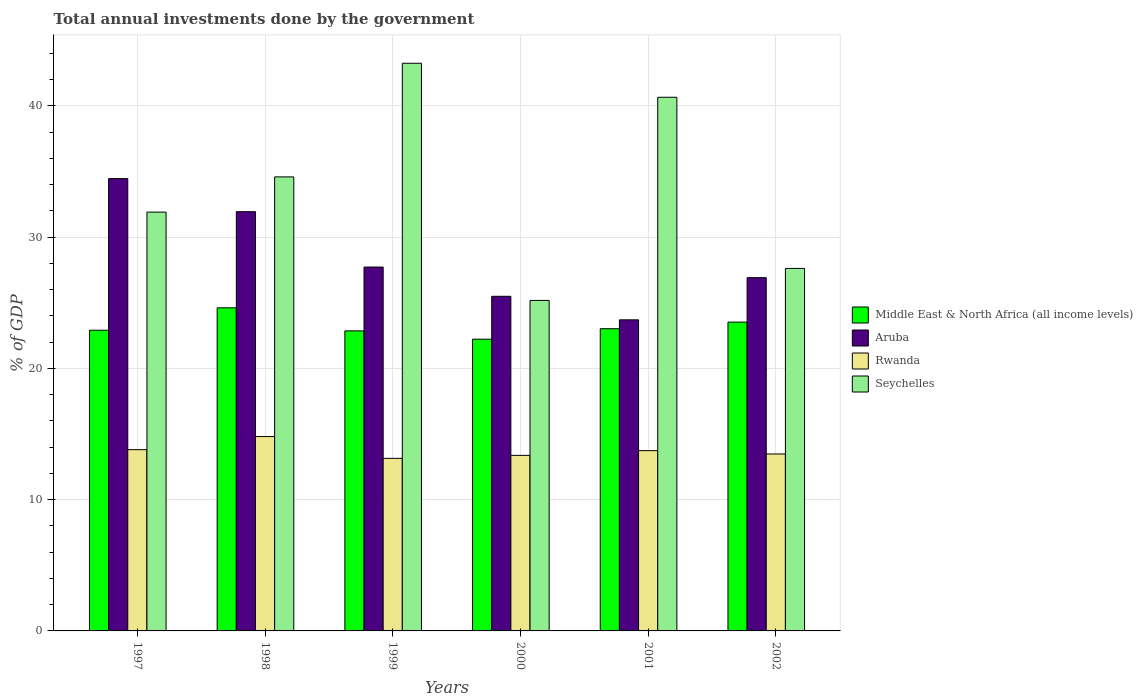What is the label of the 6th group of bars from the left?
Ensure brevity in your answer.  2002. In how many cases, is the number of bars for a given year not equal to the number of legend labels?
Keep it short and to the point. 0. What is the total annual investments done by the government in Aruba in 1997?
Your response must be concise. 34.46. Across all years, what is the maximum total annual investments done by the government in Rwanda?
Provide a short and direct response. 14.81. Across all years, what is the minimum total annual investments done by the government in Rwanda?
Ensure brevity in your answer.  13.15. In which year was the total annual investments done by the government in Seychelles maximum?
Your response must be concise. 1999. What is the total total annual investments done by the government in Middle East & North Africa (all income levels) in the graph?
Your answer should be compact. 139.17. What is the difference between the total annual investments done by the government in Seychelles in 2000 and that in 2002?
Make the answer very short. -2.44. What is the difference between the total annual investments done by the government in Middle East & North Africa (all income levels) in 2000 and the total annual investments done by the government in Seychelles in 1997?
Keep it short and to the point. -9.68. What is the average total annual investments done by the government in Middle East & North Africa (all income levels) per year?
Your answer should be very brief. 23.19. In the year 2002, what is the difference between the total annual investments done by the government in Middle East & North Africa (all income levels) and total annual investments done by the government in Aruba?
Your response must be concise. -3.39. What is the ratio of the total annual investments done by the government in Seychelles in 1998 to that in 2000?
Your response must be concise. 1.37. Is the total annual investments done by the government in Middle East & North Africa (all income levels) in 2000 less than that in 2001?
Provide a succinct answer. Yes. What is the difference between the highest and the second highest total annual investments done by the government in Middle East & North Africa (all income levels)?
Offer a terse response. 1.09. What is the difference between the highest and the lowest total annual investments done by the government in Seychelles?
Your answer should be compact. 18.07. In how many years, is the total annual investments done by the government in Aruba greater than the average total annual investments done by the government in Aruba taken over all years?
Provide a succinct answer. 2. Is the sum of the total annual investments done by the government in Aruba in 1997 and 2000 greater than the maximum total annual investments done by the government in Middle East & North Africa (all income levels) across all years?
Offer a terse response. Yes. Is it the case that in every year, the sum of the total annual investments done by the government in Middle East & North Africa (all income levels) and total annual investments done by the government in Aruba is greater than the sum of total annual investments done by the government in Rwanda and total annual investments done by the government in Seychelles?
Your response must be concise. No. What does the 1st bar from the left in 2001 represents?
Your answer should be compact. Middle East & North Africa (all income levels). What does the 4th bar from the right in 2002 represents?
Offer a very short reply. Middle East & North Africa (all income levels). Is it the case that in every year, the sum of the total annual investments done by the government in Rwanda and total annual investments done by the government in Seychelles is greater than the total annual investments done by the government in Aruba?
Your answer should be very brief. Yes. How many years are there in the graph?
Keep it short and to the point. 6. What is the difference between two consecutive major ticks on the Y-axis?
Offer a terse response. 10. Are the values on the major ticks of Y-axis written in scientific E-notation?
Your answer should be compact. No. Does the graph contain any zero values?
Your answer should be compact. No. Does the graph contain grids?
Provide a short and direct response. Yes. Where does the legend appear in the graph?
Your answer should be very brief. Center right. How many legend labels are there?
Your answer should be very brief. 4. How are the legend labels stacked?
Provide a short and direct response. Vertical. What is the title of the graph?
Keep it short and to the point. Total annual investments done by the government. What is the label or title of the X-axis?
Give a very brief answer. Years. What is the label or title of the Y-axis?
Provide a succinct answer. % of GDP. What is the % of GDP of Middle East & North Africa (all income levels) in 1997?
Your response must be concise. 22.91. What is the % of GDP in Aruba in 1997?
Make the answer very short. 34.46. What is the % of GDP in Rwanda in 1997?
Provide a succinct answer. 13.81. What is the % of GDP in Seychelles in 1997?
Ensure brevity in your answer.  31.91. What is the % of GDP in Middle East & North Africa (all income levels) in 1998?
Give a very brief answer. 24.62. What is the % of GDP of Aruba in 1998?
Your answer should be compact. 31.94. What is the % of GDP in Rwanda in 1998?
Ensure brevity in your answer.  14.81. What is the % of GDP in Seychelles in 1998?
Make the answer very short. 34.59. What is the % of GDP of Middle East & North Africa (all income levels) in 1999?
Make the answer very short. 22.86. What is the % of GDP in Aruba in 1999?
Provide a short and direct response. 27.72. What is the % of GDP in Rwanda in 1999?
Your answer should be very brief. 13.15. What is the % of GDP in Seychelles in 1999?
Your response must be concise. 43.25. What is the % of GDP of Middle East & North Africa (all income levels) in 2000?
Provide a succinct answer. 22.23. What is the % of GDP in Aruba in 2000?
Provide a succinct answer. 25.49. What is the % of GDP in Rwanda in 2000?
Provide a succinct answer. 13.38. What is the % of GDP of Seychelles in 2000?
Ensure brevity in your answer.  25.18. What is the % of GDP in Middle East & North Africa (all income levels) in 2001?
Give a very brief answer. 23.03. What is the % of GDP of Aruba in 2001?
Offer a terse response. 23.7. What is the % of GDP in Rwanda in 2001?
Provide a succinct answer. 13.74. What is the % of GDP in Seychelles in 2001?
Make the answer very short. 40.66. What is the % of GDP of Middle East & North Africa (all income levels) in 2002?
Offer a very short reply. 23.53. What is the % of GDP of Aruba in 2002?
Ensure brevity in your answer.  26.91. What is the % of GDP of Rwanda in 2002?
Keep it short and to the point. 13.48. What is the % of GDP in Seychelles in 2002?
Offer a very short reply. 27.62. Across all years, what is the maximum % of GDP in Middle East & North Africa (all income levels)?
Provide a succinct answer. 24.62. Across all years, what is the maximum % of GDP in Aruba?
Provide a short and direct response. 34.46. Across all years, what is the maximum % of GDP of Rwanda?
Your answer should be very brief. 14.81. Across all years, what is the maximum % of GDP in Seychelles?
Offer a very short reply. 43.25. Across all years, what is the minimum % of GDP in Middle East & North Africa (all income levels)?
Provide a succinct answer. 22.23. Across all years, what is the minimum % of GDP of Aruba?
Offer a very short reply. 23.7. Across all years, what is the minimum % of GDP in Rwanda?
Make the answer very short. 13.15. Across all years, what is the minimum % of GDP in Seychelles?
Make the answer very short. 25.18. What is the total % of GDP of Middle East & North Africa (all income levels) in the graph?
Your response must be concise. 139.17. What is the total % of GDP of Aruba in the graph?
Provide a succinct answer. 170.24. What is the total % of GDP of Rwanda in the graph?
Provide a succinct answer. 82.36. What is the total % of GDP in Seychelles in the graph?
Offer a very short reply. 203.21. What is the difference between the % of GDP of Middle East & North Africa (all income levels) in 1997 and that in 1998?
Offer a terse response. -1.71. What is the difference between the % of GDP of Aruba in 1997 and that in 1998?
Your answer should be very brief. 2.52. What is the difference between the % of GDP of Rwanda in 1997 and that in 1998?
Ensure brevity in your answer.  -1. What is the difference between the % of GDP in Seychelles in 1997 and that in 1998?
Provide a succinct answer. -2.68. What is the difference between the % of GDP in Middle East & North Africa (all income levels) in 1997 and that in 1999?
Offer a very short reply. 0.05. What is the difference between the % of GDP of Aruba in 1997 and that in 1999?
Ensure brevity in your answer.  6.74. What is the difference between the % of GDP in Rwanda in 1997 and that in 1999?
Make the answer very short. 0.66. What is the difference between the % of GDP in Seychelles in 1997 and that in 1999?
Offer a very short reply. -11.34. What is the difference between the % of GDP in Middle East & North Africa (all income levels) in 1997 and that in 2000?
Give a very brief answer. 0.68. What is the difference between the % of GDP in Aruba in 1997 and that in 2000?
Ensure brevity in your answer.  8.97. What is the difference between the % of GDP in Rwanda in 1997 and that in 2000?
Offer a terse response. 0.43. What is the difference between the % of GDP of Seychelles in 1997 and that in 2000?
Keep it short and to the point. 6.73. What is the difference between the % of GDP of Middle East & North Africa (all income levels) in 1997 and that in 2001?
Provide a succinct answer. -0.12. What is the difference between the % of GDP in Aruba in 1997 and that in 2001?
Keep it short and to the point. 10.76. What is the difference between the % of GDP in Rwanda in 1997 and that in 2001?
Your answer should be compact. 0.07. What is the difference between the % of GDP of Seychelles in 1997 and that in 2001?
Provide a short and direct response. -8.75. What is the difference between the % of GDP in Middle East & North Africa (all income levels) in 1997 and that in 2002?
Give a very brief answer. -0.62. What is the difference between the % of GDP in Aruba in 1997 and that in 2002?
Your answer should be very brief. 7.55. What is the difference between the % of GDP of Rwanda in 1997 and that in 2002?
Keep it short and to the point. 0.33. What is the difference between the % of GDP of Seychelles in 1997 and that in 2002?
Offer a very short reply. 4.29. What is the difference between the % of GDP in Middle East & North Africa (all income levels) in 1998 and that in 1999?
Your response must be concise. 1.76. What is the difference between the % of GDP of Aruba in 1998 and that in 1999?
Offer a terse response. 4.22. What is the difference between the % of GDP of Rwanda in 1998 and that in 1999?
Make the answer very short. 1.66. What is the difference between the % of GDP of Seychelles in 1998 and that in 1999?
Offer a terse response. -8.66. What is the difference between the % of GDP of Middle East & North Africa (all income levels) in 1998 and that in 2000?
Your answer should be very brief. 2.39. What is the difference between the % of GDP of Aruba in 1998 and that in 2000?
Keep it short and to the point. 6.45. What is the difference between the % of GDP of Rwanda in 1998 and that in 2000?
Your response must be concise. 1.43. What is the difference between the % of GDP in Seychelles in 1998 and that in 2000?
Your response must be concise. 9.41. What is the difference between the % of GDP in Middle East & North Africa (all income levels) in 1998 and that in 2001?
Provide a succinct answer. 1.59. What is the difference between the % of GDP of Aruba in 1998 and that in 2001?
Your response must be concise. 8.24. What is the difference between the % of GDP of Rwanda in 1998 and that in 2001?
Give a very brief answer. 1.07. What is the difference between the % of GDP of Seychelles in 1998 and that in 2001?
Give a very brief answer. -6.07. What is the difference between the % of GDP in Middle East & North Africa (all income levels) in 1998 and that in 2002?
Provide a succinct answer. 1.09. What is the difference between the % of GDP in Aruba in 1998 and that in 2002?
Offer a terse response. 5.03. What is the difference between the % of GDP in Rwanda in 1998 and that in 2002?
Provide a short and direct response. 1.33. What is the difference between the % of GDP in Seychelles in 1998 and that in 2002?
Ensure brevity in your answer.  6.97. What is the difference between the % of GDP in Middle East & North Africa (all income levels) in 1999 and that in 2000?
Your answer should be very brief. 0.63. What is the difference between the % of GDP of Aruba in 1999 and that in 2000?
Provide a short and direct response. 2.23. What is the difference between the % of GDP in Rwanda in 1999 and that in 2000?
Offer a terse response. -0.23. What is the difference between the % of GDP of Seychelles in 1999 and that in 2000?
Offer a very short reply. 18.07. What is the difference between the % of GDP of Middle East & North Africa (all income levels) in 1999 and that in 2001?
Make the answer very short. -0.17. What is the difference between the % of GDP in Aruba in 1999 and that in 2001?
Offer a very short reply. 4.02. What is the difference between the % of GDP in Rwanda in 1999 and that in 2001?
Keep it short and to the point. -0.59. What is the difference between the % of GDP of Seychelles in 1999 and that in 2001?
Provide a succinct answer. 2.59. What is the difference between the % of GDP in Middle East & North Africa (all income levels) in 1999 and that in 2002?
Offer a very short reply. -0.67. What is the difference between the % of GDP in Aruba in 1999 and that in 2002?
Your answer should be very brief. 0.81. What is the difference between the % of GDP in Rwanda in 1999 and that in 2002?
Make the answer very short. -0.33. What is the difference between the % of GDP in Seychelles in 1999 and that in 2002?
Offer a very short reply. 15.63. What is the difference between the % of GDP of Middle East & North Africa (all income levels) in 2000 and that in 2001?
Keep it short and to the point. -0.8. What is the difference between the % of GDP in Aruba in 2000 and that in 2001?
Your answer should be compact. 1.79. What is the difference between the % of GDP in Rwanda in 2000 and that in 2001?
Provide a short and direct response. -0.36. What is the difference between the % of GDP in Seychelles in 2000 and that in 2001?
Offer a very short reply. -15.48. What is the difference between the % of GDP of Middle East & North Africa (all income levels) in 2000 and that in 2002?
Your answer should be compact. -1.3. What is the difference between the % of GDP in Aruba in 2000 and that in 2002?
Your answer should be very brief. -1.42. What is the difference between the % of GDP of Rwanda in 2000 and that in 2002?
Ensure brevity in your answer.  -0.11. What is the difference between the % of GDP of Seychelles in 2000 and that in 2002?
Provide a succinct answer. -2.44. What is the difference between the % of GDP of Middle East & North Africa (all income levels) in 2001 and that in 2002?
Your response must be concise. -0.5. What is the difference between the % of GDP of Aruba in 2001 and that in 2002?
Keep it short and to the point. -3.21. What is the difference between the % of GDP of Rwanda in 2001 and that in 2002?
Make the answer very short. 0.25. What is the difference between the % of GDP in Seychelles in 2001 and that in 2002?
Give a very brief answer. 13.04. What is the difference between the % of GDP in Middle East & North Africa (all income levels) in 1997 and the % of GDP in Aruba in 1998?
Provide a short and direct response. -9.03. What is the difference between the % of GDP in Middle East & North Africa (all income levels) in 1997 and the % of GDP in Rwanda in 1998?
Ensure brevity in your answer.  8.1. What is the difference between the % of GDP in Middle East & North Africa (all income levels) in 1997 and the % of GDP in Seychelles in 1998?
Your answer should be compact. -11.68. What is the difference between the % of GDP in Aruba in 1997 and the % of GDP in Rwanda in 1998?
Provide a succinct answer. 19.66. What is the difference between the % of GDP in Aruba in 1997 and the % of GDP in Seychelles in 1998?
Give a very brief answer. -0.13. What is the difference between the % of GDP of Rwanda in 1997 and the % of GDP of Seychelles in 1998?
Make the answer very short. -20.78. What is the difference between the % of GDP in Middle East & North Africa (all income levels) in 1997 and the % of GDP in Aruba in 1999?
Your response must be concise. -4.82. What is the difference between the % of GDP in Middle East & North Africa (all income levels) in 1997 and the % of GDP in Rwanda in 1999?
Keep it short and to the point. 9.76. What is the difference between the % of GDP of Middle East & North Africa (all income levels) in 1997 and the % of GDP of Seychelles in 1999?
Keep it short and to the point. -20.34. What is the difference between the % of GDP in Aruba in 1997 and the % of GDP in Rwanda in 1999?
Make the answer very short. 21.32. What is the difference between the % of GDP of Aruba in 1997 and the % of GDP of Seychelles in 1999?
Your response must be concise. -8.79. What is the difference between the % of GDP in Rwanda in 1997 and the % of GDP in Seychelles in 1999?
Make the answer very short. -29.44. What is the difference between the % of GDP of Middle East & North Africa (all income levels) in 1997 and the % of GDP of Aruba in 2000?
Your response must be concise. -2.59. What is the difference between the % of GDP of Middle East & North Africa (all income levels) in 1997 and the % of GDP of Rwanda in 2000?
Your response must be concise. 9.53. What is the difference between the % of GDP in Middle East & North Africa (all income levels) in 1997 and the % of GDP in Seychelles in 2000?
Provide a succinct answer. -2.27. What is the difference between the % of GDP in Aruba in 1997 and the % of GDP in Rwanda in 2000?
Ensure brevity in your answer.  21.09. What is the difference between the % of GDP in Aruba in 1997 and the % of GDP in Seychelles in 2000?
Give a very brief answer. 9.28. What is the difference between the % of GDP of Rwanda in 1997 and the % of GDP of Seychelles in 2000?
Make the answer very short. -11.37. What is the difference between the % of GDP in Middle East & North Africa (all income levels) in 1997 and the % of GDP in Aruba in 2001?
Make the answer very short. -0.79. What is the difference between the % of GDP in Middle East & North Africa (all income levels) in 1997 and the % of GDP in Rwanda in 2001?
Offer a very short reply. 9.17. What is the difference between the % of GDP of Middle East & North Africa (all income levels) in 1997 and the % of GDP of Seychelles in 2001?
Keep it short and to the point. -17.75. What is the difference between the % of GDP in Aruba in 1997 and the % of GDP in Rwanda in 2001?
Ensure brevity in your answer.  20.73. What is the difference between the % of GDP of Aruba in 1997 and the % of GDP of Seychelles in 2001?
Your response must be concise. -6.2. What is the difference between the % of GDP in Rwanda in 1997 and the % of GDP in Seychelles in 2001?
Provide a succinct answer. -26.85. What is the difference between the % of GDP of Middle East & North Africa (all income levels) in 1997 and the % of GDP of Aruba in 2002?
Offer a very short reply. -4.01. What is the difference between the % of GDP in Middle East & North Africa (all income levels) in 1997 and the % of GDP in Rwanda in 2002?
Offer a terse response. 9.43. What is the difference between the % of GDP in Middle East & North Africa (all income levels) in 1997 and the % of GDP in Seychelles in 2002?
Your answer should be compact. -4.71. What is the difference between the % of GDP in Aruba in 1997 and the % of GDP in Rwanda in 2002?
Your answer should be compact. 20.98. What is the difference between the % of GDP of Aruba in 1997 and the % of GDP of Seychelles in 2002?
Your answer should be compact. 6.84. What is the difference between the % of GDP in Rwanda in 1997 and the % of GDP in Seychelles in 2002?
Keep it short and to the point. -13.81. What is the difference between the % of GDP in Middle East & North Africa (all income levels) in 1998 and the % of GDP in Aruba in 1999?
Your answer should be compact. -3.11. What is the difference between the % of GDP in Middle East & North Africa (all income levels) in 1998 and the % of GDP in Rwanda in 1999?
Provide a short and direct response. 11.47. What is the difference between the % of GDP in Middle East & North Africa (all income levels) in 1998 and the % of GDP in Seychelles in 1999?
Ensure brevity in your answer.  -18.63. What is the difference between the % of GDP in Aruba in 1998 and the % of GDP in Rwanda in 1999?
Your answer should be compact. 18.79. What is the difference between the % of GDP of Aruba in 1998 and the % of GDP of Seychelles in 1999?
Ensure brevity in your answer.  -11.31. What is the difference between the % of GDP of Rwanda in 1998 and the % of GDP of Seychelles in 1999?
Provide a short and direct response. -28.44. What is the difference between the % of GDP in Middle East & North Africa (all income levels) in 1998 and the % of GDP in Aruba in 2000?
Provide a succinct answer. -0.88. What is the difference between the % of GDP of Middle East & North Africa (all income levels) in 1998 and the % of GDP of Rwanda in 2000?
Your response must be concise. 11.24. What is the difference between the % of GDP of Middle East & North Africa (all income levels) in 1998 and the % of GDP of Seychelles in 2000?
Make the answer very short. -0.56. What is the difference between the % of GDP in Aruba in 1998 and the % of GDP in Rwanda in 2000?
Keep it short and to the point. 18.57. What is the difference between the % of GDP in Aruba in 1998 and the % of GDP in Seychelles in 2000?
Your answer should be very brief. 6.76. What is the difference between the % of GDP of Rwanda in 1998 and the % of GDP of Seychelles in 2000?
Offer a very short reply. -10.37. What is the difference between the % of GDP in Middle East & North Africa (all income levels) in 1998 and the % of GDP in Aruba in 2001?
Your answer should be very brief. 0.92. What is the difference between the % of GDP of Middle East & North Africa (all income levels) in 1998 and the % of GDP of Rwanda in 2001?
Your answer should be compact. 10.88. What is the difference between the % of GDP of Middle East & North Africa (all income levels) in 1998 and the % of GDP of Seychelles in 2001?
Your answer should be very brief. -16.04. What is the difference between the % of GDP of Aruba in 1998 and the % of GDP of Rwanda in 2001?
Make the answer very short. 18.21. What is the difference between the % of GDP in Aruba in 1998 and the % of GDP in Seychelles in 2001?
Give a very brief answer. -8.72. What is the difference between the % of GDP in Rwanda in 1998 and the % of GDP in Seychelles in 2001?
Your answer should be compact. -25.85. What is the difference between the % of GDP in Middle East & North Africa (all income levels) in 1998 and the % of GDP in Aruba in 2002?
Your answer should be compact. -2.3. What is the difference between the % of GDP of Middle East & North Africa (all income levels) in 1998 and the % of GDP of Rwanda in 2002?
Your answer should be compact. 11.14. What is the difference between the % of GDP of Middle East & North Africa (all income levels) in 1998 and the % of GDP of Seychelles in 2002?
Your answer should be very brief. -3. What is the difference between the % of GDP in Aruba in 1998 and the % of GDP in Rwanda in 2002?
Give a very brief answer. 18.46. What is the difference between the % of GDP of Aruba in 1998 and the % of GDP of Seychelles in 2002?
Provide a succinct answer. 4.32. What is the difference between the % of GDP in Rwanda in 1998 and the % of GDP in Seychelles in 2002?
Ensure brevity in your answer.  -12.81. What is the difference between the % of GDP of Middle East & North Africa (all income levels) in 1999 and the % of GDP of Aruba in 2000?
Provide a short and direct response. -2.63. What is the difference between the % of GDP in Middle East & North Africa (all income levels) in 1999 and the % of GDP in Rwanda in 2000?
Your answer should be very brief. 9.48. What is the difference between the % of GDP of Middle East & North Africa (all income levels) in 1999 and the % of GDP of Seychelles in 2000?
Your answer should be compact. -2.32. What is the difference between the % of GDP of Aruba in 1999 and the % of GDP of Rwanda in 2000?
Offer a very short reply. 14.35. What is the difference between the % of GDP in Aruba in 1999 and the % of GDP in Seychelles in 2000?
Ensure brevity in your answer.  2.54. What is the difference between the % of GDP in Rwanda in 1999 and the % of GDP in Seychelles in 2000?
Provide a succinct answer. -12.03. What is the difference between the % of GDP in Middle East & North Africa (all income levels) in 1999 and the % of GDP in Aruba in 2001?
Your answer should be very brief. -0.84. What is the difference between the % of GDP in Middle East & North Africa (all income levels) in 1999 and the % of GDP in Rwanda in 2001?
Your answer should be very brief. 9.12. What is the difference between the % of GDP of Middle East & North Africa (all income levels) in 1999 and the % of GDP of Seychelles in 2001?
Your response must be concise. -17.8. What is the difference between the % of GDP in Aruba in 1999 and the % of GDP in Rwanda in 2001?
Your response must be concise. 13.99. What is the difference between the % of GDP of Aruba in 1999 and the % of GDP of Seychelles in 2001?
Give a very brief answer. -12.94. What is the difference between the % of GDP in Rwanda in 1999 and the % of GDP in Seychelles in 2001?
Keep it short and to the point. -27.51. What is the difference between the % of GDP of Middle East & North Africa (all income levels) in 1999 and the % of GDP of Aruba in 2002?
Give a very brief answer. -4.05. What is the difference between the % of GDP in Middle East & North Africa (all income levels) in 1999 and the % of GDP in Rwanda in 2002?
Your response must be concise. 9.38. What is the difference between the % of GDP of Middle East & North Africa (all income levels) in 1999 and the % of GDP of Seychelles in 2002?
Give a very brief answer. -4.76. What is the difference between the % of GDP of Aruba in 1999 and the % of GDP of Rwanda in 2002?
Your answer should be compact. 14.24. What is the difference between the % of GDP in Aruba in 1999 and the % of GDP in Seychelles in 2002?
Provide a short and direct response. 0.1. What is the difference between the % of GDP of Rwanda in 1999 and the % of GDP of Seychelles in 2002?
Give a very brief answer. -14.47. What is the difference between the % of GDP in Middle East & North Africa (all income levels) in 2000 and the % of GDP in Aruba in 2001?
Your answer should be compact. -1.47. What is the difference between the % of GDP in Middle East & North Africa (all income levels) in 2000 and the % of GDP in Rwanda in 2001?
Make the answer very short. 8.49. What is the difference between the % of GDP of Middle East & North Africa (all income levels) in 2000 and the % of GDP of Seychelles in 2001?
Ensure brevity in your answer.  -18.43. What is the difference between the % of GDP of Aruba in 2000 and the % of GDP of Rwanda in 2001?
Offer a very short reply. 11.76. What is the difference between the % of GDP in Aruba in 2000 and the % of GDP in Seychelles in 2001?
Your answer should be very brief. -15.17. What is the difference between the % of GDP of Rwanda in 2000 and the % of GDP of Seychelles in 2001?
Offer a very short reply. -27.28. What is the difference between the % of GDP of Middle East & North Africa (all income levels) in 2000 and the % of GDP of Aruba in 2002?
Ensure brevity in your answer.  -4.69. What is the difference between the % of GDP in Middle East & North Africa (all income levels) in 2000 and the % of GDP in Rwanda in 2002?
Make the answer very short. 8.75. What is the difference between the % of GDP of Middle East & North Africa (all income levels) in 2000 and the % of GDP of Seychelles in 2002?
Keep it short and to the point. -5.39. What is the difference between the % of GDP in Aruba in 2000 and the % of GDP in Rwanda in 2002?
Give a very brief answer. 12.01. What is the difference between the % of GDP in Aruba in 2000 and the % of GDP in Seychelles in 2002?
Give a very brief answer. -2.13. What is the difference between the % of GDP in Rwanda in 2000 and the % of GDP in Seychelles in 2002?
Your response must be concise. -14.24. What is the difference between the % of GDP of Middle East & North Africa (all income levels) in 2001 and the % of GDP of Aruba in 2002?
Your answer should be very brief. -3.89. What is the difference between the % of GDP in Middle East & North Africa (all income levels) in 2001 and the % of GDP in Rwanda in 2002?
Keep it short and to the point. 9.54. What is the difference between the % of GDP of Middle East & North Africa (all income levels) in 2001 and the % of GDP of Seychelles in 2002?
Keep it short and to the point. -4.59. What is the difference between the % of GDP in Aruba in 2001 and the % of GDP in Rwanda in 2002?
Your answer should be very brief. 10.22. What is the difference between the % of GDP in Aruba in 2001 and the % of GDP in Seychelles in 2002?
Ensure brevity in your answer.  -3.92. What is the difference between the % of GDP in Rwanda in 2001 and the % of GDP in Seychelles in 2002?
Your answer should be compact. -13.88. What is the average % of GDP in Middle East & North Africa (all income levels) per year?
Make the answer very short. 23.19. What is the average % of GDP of Aruba per year?
Offer a very short reply. 28.37. What is the average % of GDP of Rwanda per year?
Your answer should be very brief. 13.73. What is the average % of GDP in Seychelles per year?
Offer a terse response. 33.87. In the year 1997, what is the difference between the % of GDP of Middle East & North Africa (all income levels) and % of GDP of Aruba?
Provide a succinct answer. -11.56. In the year 1997, what is the difference between the % of GDP in Middle East & North Africa (all income levels) and % of GDP in Rwanda?
Keep it short and to the point. 9.1. In the year 1997, what is the difference between the % of GDP of Middle East & North Africa (all income levels) and % of GDP of Seychelles?
Make the answer very short. -9. In the year 1997, what is the difference between the % of GDP of Aruba and % of GDP of Rwanda?
Provide a succinct answer. 20.65. In the year 1997, what is the difference between the % of GDP in Aruba and % of GDP in Seychelles?
Keep it short and to the point. 2.55. In the year 1997, what is the difference between the % of GDP of Rwanda and % of GDP of Seychelles?
Your response must be concise. -18.1. In the year 1998, what is the difference between the % of GDP in Middle East & North Africa (all income levels) and % of GDP in Aruba?
Your answer should be very brief. -7.33. In the year 1998, what is the difference between the % of GDP of Middle East & North Africa (all income levels) and % of GDP of Rwanda?
Keep it short and to the point. 9.81. In the year 1998, what is the difference between the % of GDP of Middle East & North Africa (all income levels) and % of GDP of Seychelles?
Keep it short and to the point. -9.97. In the year 1998, what is the difference between the % of GDP in Aruba and % of GDP in Rwanda?
Give a very brief answer. 17.14. In the year 1998, what is the difference between the % of GDP of Aruba and % of GDP of Seychelles?
Keep it short and to the point. -2.65. In the year 1998, what is the difference between the % of GDP of Rwanda and % of GDP of Seychelles?
Ensure brevity in your answer.  -19.78. In the year 1999, what is the difference between the % of GDP in Middle East & North Africa (all income levels) and % of GDP in Aruba?
Make the answer very short. -4.86. In the year 1999, what is the difference between the % of GDP in Middle East & North Africa (all income levels) and % of GDP in Rwanda?
Give a very brief answer. 9.71. In the year 1999, what is the difference between the % of GDP of Middle East & North Africa (all income levels) and % of GDP of Seychelles?
Give a very brief answer. -20.39. In the year 1999, what is the difference between the % of GDP in Aruba and % of GDP in Rwanda?
Your response must be concise. 14.57. In the year 1999, what is the difference between the % of GDP of Aruba and % of GDP of Seychelles?
Your answer should be compact. -15.53. In the year 1999, what is the difference between the % of GDP in Rwanda and % of GDP in Seychelles?
Offer a very short reply. -30.1. In the year 2000, what is the difference between the % of GDP in Middle East & North Africa (all income levels) and % of GDP in Aruba?
Make the answer very short. -3.27. In the year 2000, what is the difference between the % of GDP of Middle East & North Africa (all income levels) and % of GDP of Rwanda?
Your answer should be compact. 8.85. In the year 2000, what is the difference between the % of GDP of Middle East & North Africa (all income levels) and % of GDP of Seychelles?
Provide a short and direct response. -2.95. In the year 2000, what is the difference between the % of GDP in Aruba and % of GDP in Rwanda?
Offer a terse response. 12.12. In the year 2000, what is the difference between the % of GDP of Aruba and % of GDP of Seychelles?
Provide a short and direct response. 0.31. In the year 2000, what is the difference between the % of GDP of Rwanda and % of GDP of Seychelles?
Your answer should be very brief. -11.81. In the year 2001, what is the difference between the % of GDP of Middle East & North Africa (all income levels) and % of GDP of Aruba?
Give a very brief answer. -0.68. In the year 2001, what is the difference between the % of GDP in Middle East & North Africa (all income levels) and % of GDP in Rwanda?
Offer a terse response. 9.29. In the year 2001, what is the difference between the % of GDP of Middle East & North Africa (all income levels) and % of GDP of Seychelles?
Keep it short and to the point. -17.63. In the year 2001, what is the difference between the % of GDP in Aruba and % of GDP in Rwanda?
Provide a succinct answer. 9.97. In the year 2001, what is the difference between the % of GDP in Aruba and % of GDP in Seychelles?
Make the answer very short. -16.96. In the year 2001, what is the difference between the % of GDP of Rwanda and % of GDP of Seychelles?
Offer a terse response. -26.92. In the year 2002, what is the difference between the % of GDP of Middle East & North Africa (all income levels) and % of GDP of Aruba?
Give a very brief answer. -3.39. In the year 2002, what is the difference between the % of GDP in Middle East & North Africa (all income levels) and % of GDP in Rwanda?
Offer a very short reply. 10.05. In the year 2002, what is the difference between the % of GDP of Middle East & North Africa (all income levels) and % of GDP of Seychelles?
Give a very brief answer. -4.09. In the year 2002, what is the difference between the % of GDP in Aruba and % of GDP in Rwanda?
Offer a very short reply. 13.43. In the year 2002, what is the difference between the % of GDP of Aruba and % of GDP of Seychelles?
Keep it short and to the point. -0.7. In the year 2002, what is the difference between the % of GDP in Rwanda and % of GDP in Seychelles?
Your response must be concise. -14.14. What is the ratio of the % of GDP of Middle East & North Africa (all income levels) in 1997 to that in 1998?
Make the answer very short. 0.93. What is the ratio of the % of GDP in Aruba in 1997 to that in 1998?
Offer a very short reply. 1.08. What is the ratio of the % of GDP of Rwanda in 1997 to that in 1998?
Give a very brief answer. 0.93. What is the ratio of the % of GDP of Seychelles in 1997 to that in 1998?
Your answer should be compact. 0.92. What is the ratio of the % of GDP in Aruba in 1997 to that in 1999?
Keep it short and to the point. 1.24. What is the ratio of the % of GDP of Rwanda in 1997 to that in 1999?
Keep it short and to the point. 1.05. What is the ratio of the % of GDP in Seychelles in 1997 to that in 1999?
Your answer should be compact. 0.74. What is the ratio of the % of GDP in Middle East & North Africa (all income levels) in 1997 to that in 2000?
Your answer should be compact. 1.03. What is the ratio of the % of GDP in Aruba in 1997 to that in 2000?
Give a very brief answer. 1.35. What is the ratio of the % of GDP of Rwanda in 1997 to that in 2000?
Make the answer very short. 1.03. What is the ratio of the % of GDP of Seychelles in 1997 to that in 2000?
Keep it short and to the point. 1.27. What is the ratio of the % of GDP of Aruba in 1997 to that in 2001?
Your answer should be compact. 1.45. What is the ratio of the % of GDP of Rwanda in 1997 to that in 2001?
Your answer should be compact. 1.01. What is the ratio of the % of GDP in Seychelles in 1997 to that in 2001?
Your answer should be compact. 0.78. What is the ratio of the % of GDP in Middle East & North Africa (all income levels) in 1997 to that in 2002?
Give a very brief answer. 0.97. What is the ratio of the % of GDP in Aruba in 1997 to that in 2002?
Your answer should be very brief. 1.28. What is the ratio of the % of GDP of Rwanda in 1997 to that in 2002?
Keep it short and to the point. 1.02. What is the ratio of the % of GDP of Seychelles in 1997 to that in 2002?
Offer a very short reply. 1.16. What is the ratio of the % of GDP of Middle East & North Africa (all income levels) in 1998 to that in 1999?
Offer a terse response. 1.08. What is the ratio of the % of GDP in Aruba in 1998 to that in 1999?
Keep it short and to the point. 1.15. What is the ratio of the % of GDP in Rwanda in 1998 to that in 1999?
Keep it short and to the point. 1.13. What is the ratio of the % of GDP in Seychelles in 1998 to that in 1999?
Make the answer very short. 0.8. What is the ratio of the % of GDP of Middle East & North Africa (all income levels) in 1998 to that in 2000?
Your response must be concise. 1.11. What is the ratio of the % of GDP in Aruba in 1998 to that in 2000?
Your answer should be compact. 1.25. What is the ratio of the % of GDP of Rwanda in 1998 to that in 2000?
Ensure brevity in your answer.  1.11. What is the ratio of the % of GDP in Seychelles in 1998 to that in 2000?
Ensure brevity in your answer.  1.37. What is the ratio of the % of GDP of Middle East & North Africa (all income levels) in 1998 to that in 2001?
Your response must be concise. 1.07. What is the ratio of the % of GDP in Aruba in 1998 to that in 2001?
Provide a short and direct response. 1.35. What is the ratio of the % of GDP in Rwanda in 1998 to that in 2001?
Your answer should be very brief. 1.08. What is the ratio of the % of GDP in Seychelles in 1998 to that in 2001?
Provide a short and direct response. 0.85. What is the ratio of the % of GDP in Middle East & North Africa (all income levels) in 1998 to that in 2002?
Offer a terse response. 1.05. What is the ratio of the % of GDP of Aruba in 1998 to that in 2002?
Offer a terse response. 1.19. What is the ratio of the % of GDP in Rwanda in 1998 to that in 2002?
Make the answer very short. 1.1. What is the ratio of the % of GDP in Seychelles in 1998 to that in 2002?
Keep it short and to the point. 1.25. What is the ratio of the % of GDP in Middle East & North Africa (all income levels) in 1999 to that in 2000?
Your answer should be compact. 1.03. What is the ratio of the % of GDP in Aruba in 1999 to that in 2000?
Your answer should be compact. 1.09. What is the ratio of the % of GDP of Rwanda in 1999 to that in 2000?
Provide a short and direct response. 0.98. What is the ratio of the % of GDP of Seychelles in 1999 to that in 2000?
Your answer should be compact. 1.72. What is the ratio of the % of GDP of Middle East & North Africa (all income levels) in 1999 to that in 2001?
Your answer should be very brief. 0.99. What is the ratio of the % of GDP in Aruba in 1999 to that in 2001?
Your answer should be very brief. 1.17. What is the ratio of the % of GDP in Rwanda in 1999 to that in 2001?
Your answer should be very brief. 0.96. What is the ratio of the % of GDP of Seychelles in 1999 to that in 2001?
Keep it short and to the point. 1.06. What is the ratio of the % of GDP of Middle East & North Africa (all income levels) in 1999 to that in 2002?
Your response must be concise. 0.97. What is the ratio of the % of GDP in Aruba in 1999 to that in 2002?
Your answer should be very brief. 1.03. What is the ratio of the % of GDP of Rwanda in 1999 to that in 2002?
Make the answer very short. 0.98. What is the ratio of the % of GDP in Seychelles in 1999 to that in 2002?
Provide a succinct answer. 1.57. What is the ratio of the % of GDP in Middle East & North Africa (all income levels) in 2000 to that in 2001?
Your response must be concise. 0.97. What is the ratio of the % of GDP in Aruba in 2000 to that in 2001?
Ensure brevity in your answer.  1.08. What is the ratio of the % of GDP of Rwanda in 2000 to that in 2001?
Provide a short and direct response. 0.97. What is the ratio of the % of GDP in Seychelles in 2000 to that in 2001?
Offer a terse response. 0.62. What is the ratio of the % of GDP in Middle East & North Africa (all income levels) in 2000 to that in 2002?
Your response must be concise. 0.94. What is the ratio of the % of GDP of Aruba in 2000 to that in 2002?
Ensure brevity in your answer.  0.95. What is the ratio of the % of GDP in Rwanda in 2000 to that in 2002?
Make the answer very short. 0.99. What is the ratio of the % of GDP in Seychelles in 2000 to that in 2002?
Offer a terse response. 0.91. What is the ratio of the % of GDP of Middle East & North Africa (all income levels) in 2001 to that in 2002?
Offer a terse response. 0.98. What is the ratio of the % of GDP in Aruba in 2001 to that in 2002?
Your answer should be compact. 0.88. What is the ratio of the % of GDP of Rwanda in 2001 to that in 2002?
Your answer should be compact. 1.02. What is the ratio of the % of GDP of Seychelles in 2001 to that in 2002?
Provide a short and direct response. 1.47. What is the difference between the highest and the second highest % of GDP in Middle East & North Africa (all income levels)?
Offer a terse response. 1.09. What is the difference between the highest and the second highest % of GDP of Aruba?
Make the answer very short. 2.52. What is the difference between the highest and the second highest % of GDP in Rwanda?
Offer a very short reply. 1. What is the difference between the highest and the second highest % of GDP in Seychelles?
Your response must be concise. 2.59. What is the difference between the highest and the lowest % of GDP in Middle East & North Africa (all income levels)?
Give a very brief answer. 2.39. What is the difference between the highest and the lowest % of GDP in Aruba?
Your answer should be very brief. 10.76. What is the difference between the highest and the lowest % of GDP of Rwanda?
Ensure brevity in your answer.  1.66. What is the difference between the highest and the lowest % of GDP of Seychelles?
Offer a terse response. 18.07. 